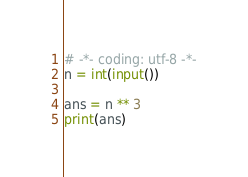<code> <loc_0><loc_0><loc_500><loc_500><_Python_># -*- coding: utf-8 -*-
n = int(input())

ans = n ** 3
print(ans)
</code> 